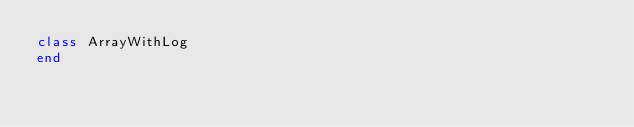Convert code to text. <code><loc_0><loc_0><loc_500><loc_500><_Ruby_>class ArrayWithLog
end
</code> 